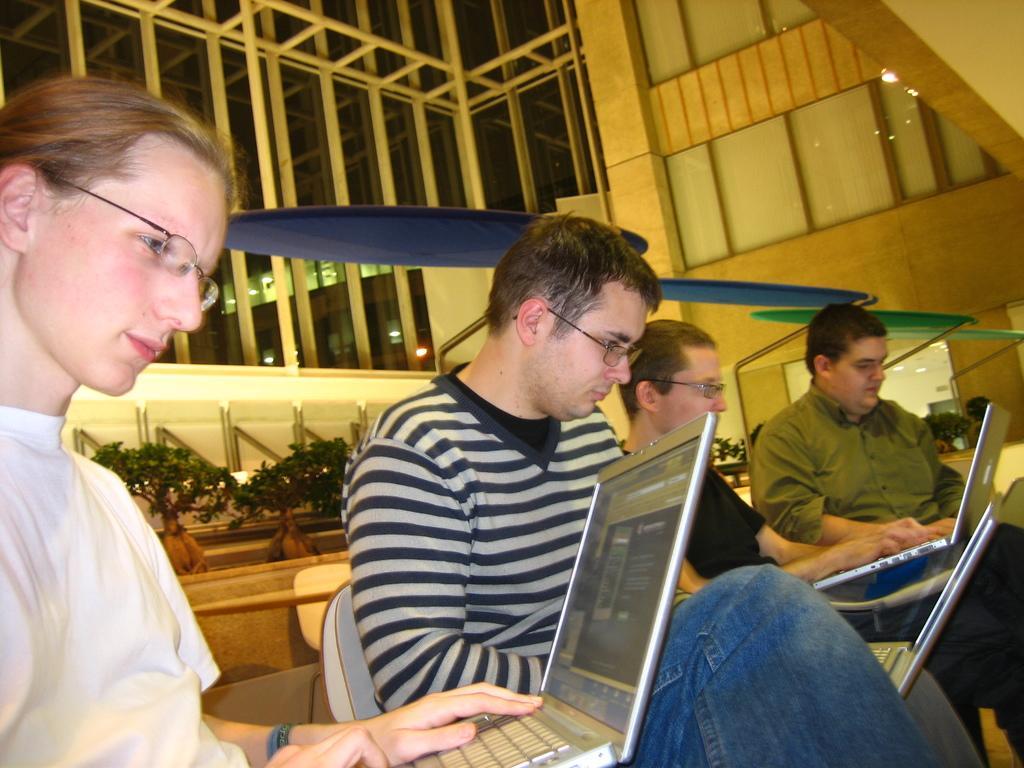Please provide a concise description of this image. In this image we can see four persons and the persons are holding laptops. Behind the persons we can see chairs, wall and plants. At the top we can see the wall and glasses. 